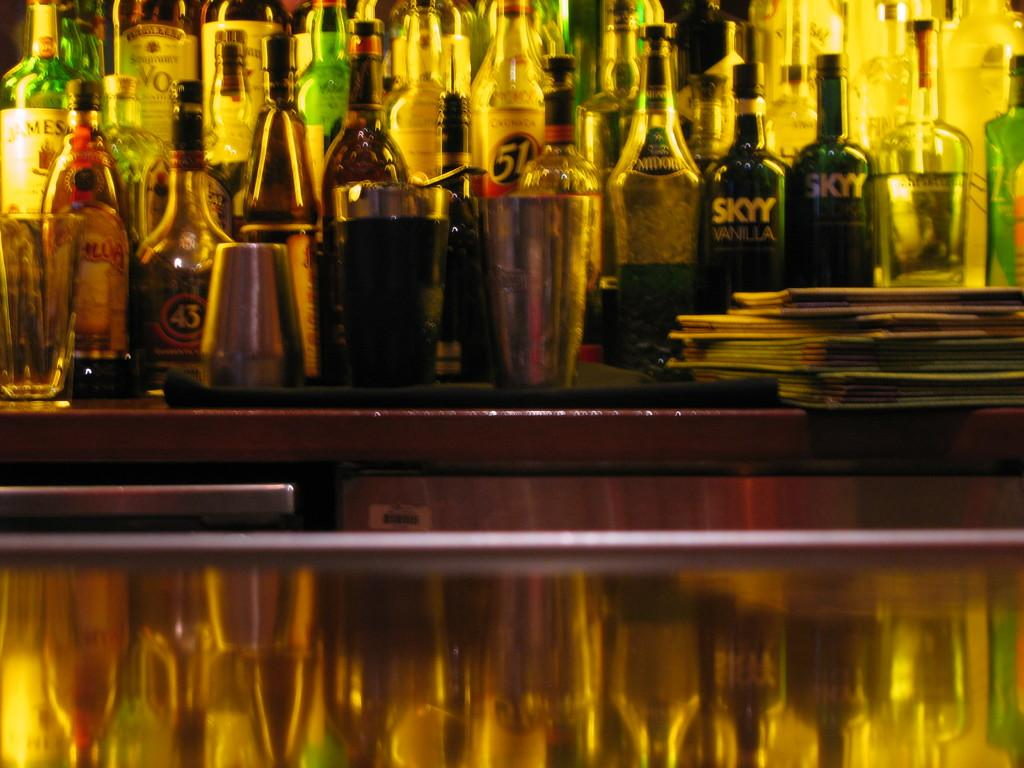<image>
Offer a succinct explanation of the picture presented. Many alcohol bottles are situated across the bar, one being SKYY vodka 